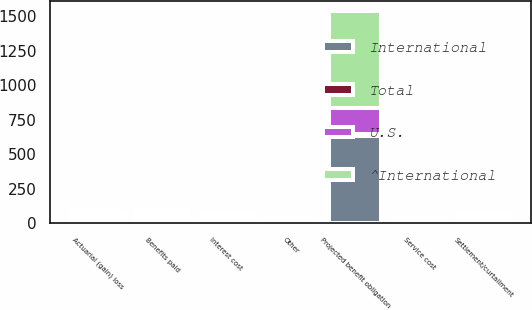<chart> <loc_0><loc_0><loc_500><loc_500><stacked_bar_chart><ecel><fcel>Projected benefit obligation<fcel>Service cost<fcel>Interest cost<fcel>Actuarial (gain) loss<fcel>Settlement/curtailment<fcel>Benefits paid<fcel>Other<nl><fcel>U.S.<fcel>182.1<fcel>0.1<fcel>6.5<fcel>10.6<fcel>7.6<fcel>11.2<fcel>0.2<nl><fcel>International<fcel>633.5<fcel>4.2<fcel>15.2<fcel>21.5<fcel>15.1<fcel>22.9<fcel>5.8<nl><fcel>Total<fcel>16.1<fcel>4.3<fcel>21.7<fcel>32.1<fcel>22.7<fcel>34.1<fcel>6<nl><fcel>^International<fcel>702.2<fcel>6.9<fcel>16.1<fcel>16.5<fcel>21.2<fcel>22.6<fcel>1.1<nl></chart> 